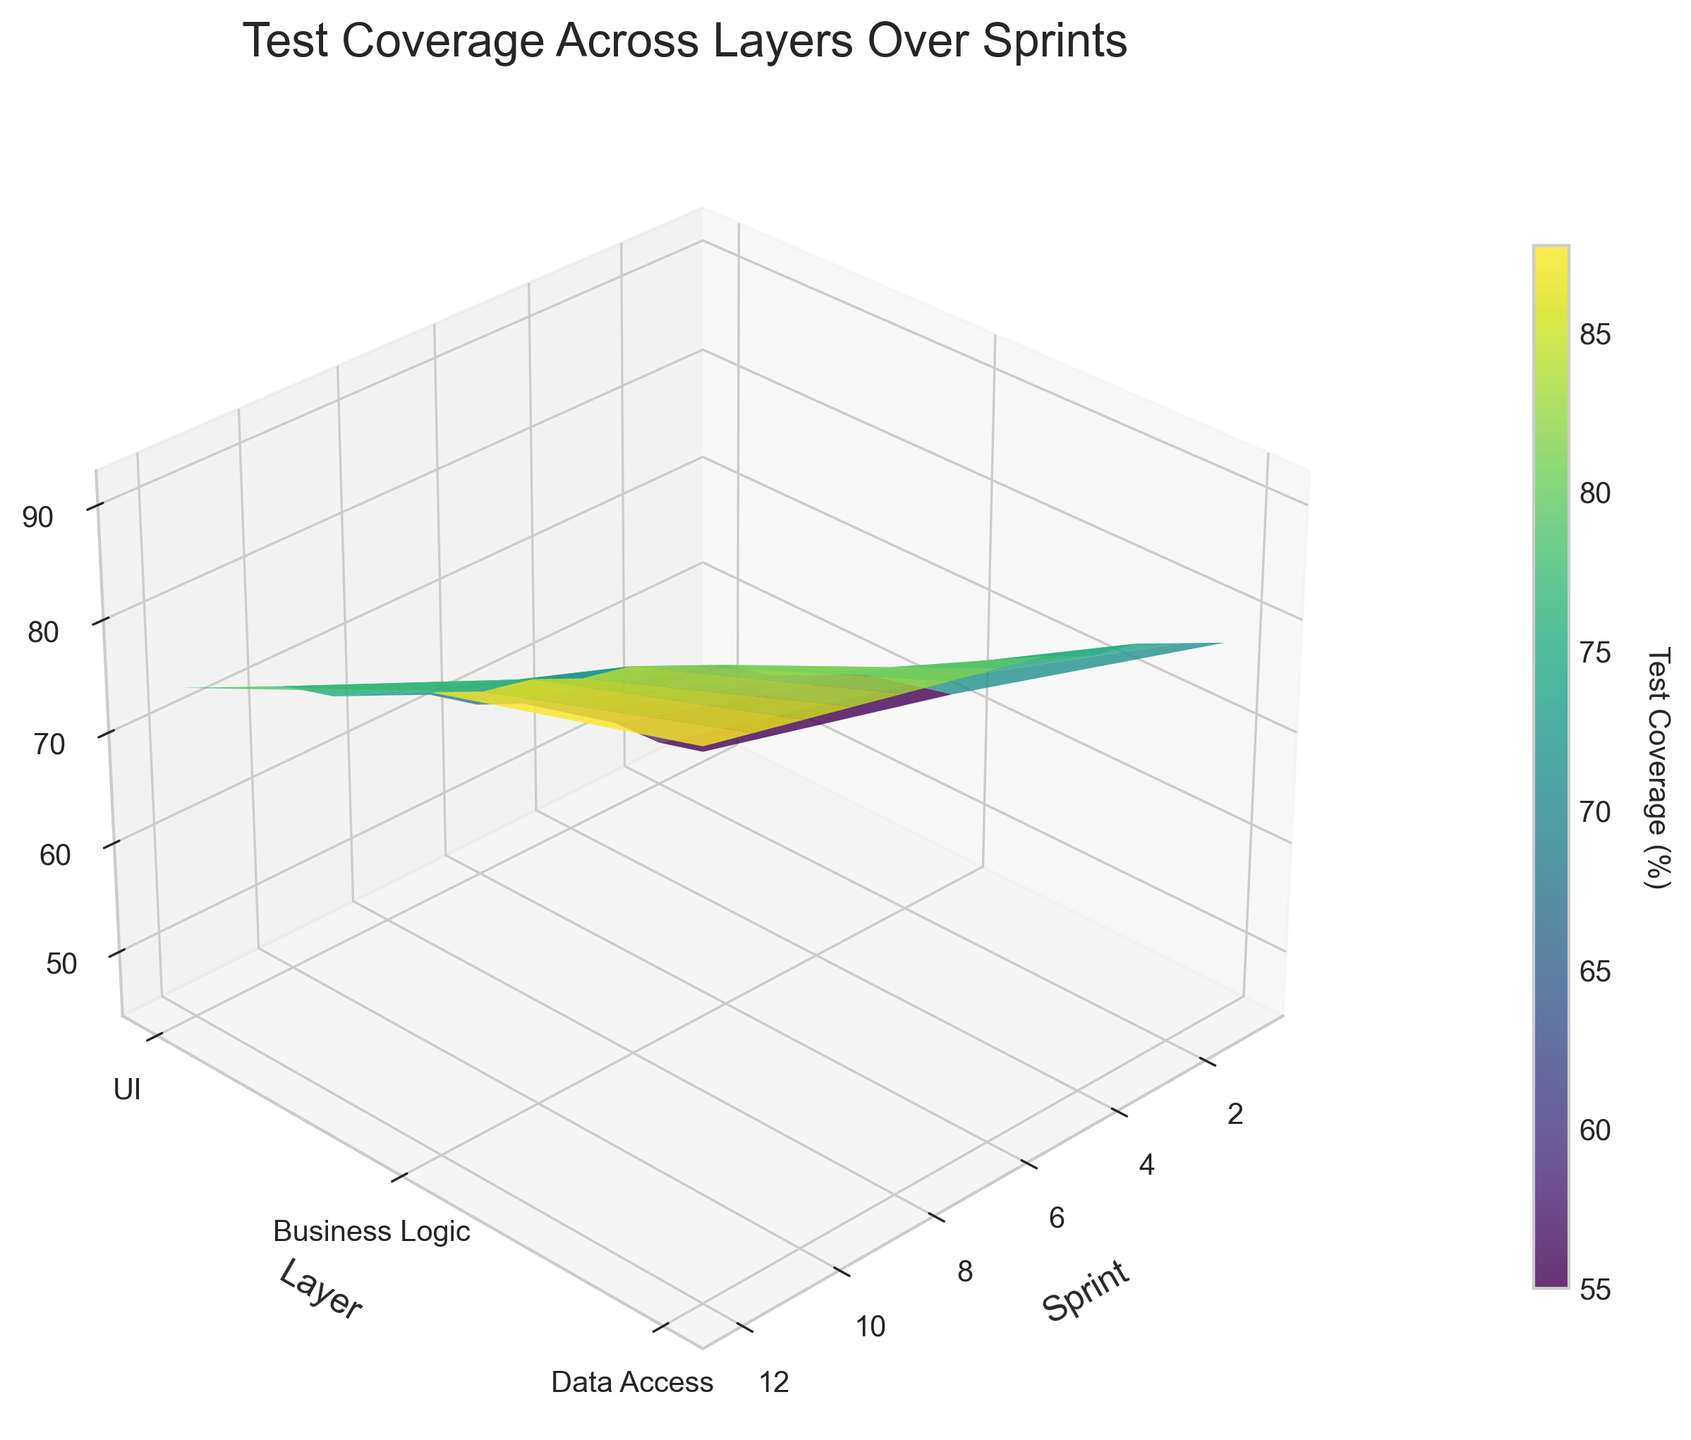What is the title of the plot? The title of the plot is positioned at the top center of the figure. It is displayed clearly in a large font.
Answer: Test Coverage Across Layers Over Sprints What are the labels for the X, Y, and Z axes? The labels for the axes are clearly marked along each axis. X is labeled “Sprint,” Y is labeled “Layer,” and Z is labeled “Test Coverage (%)”.
Answer: X: Sprint, Y: Layer, Z: Test Coverage (%) Which layer has the highest test coverage at Sprint 6? You need to identify the test coverage values for each layer at Sprint 6. Look at the specific point for Sprint 6 along the Z-axis for each layer mentioned along the Y-axis. The Data Access Layer has the highest value.
Answer: Data Access Layer How does the test coverage percentage for the UI Layer change from Sprint 1 to Sprint 12? Follow the trend along the Z-axis for the UI Layer from Sprint 1 to Sprint 12. You see an upward trend indicating that the test coverage for the UI Layer increases from around 45% to 74%.
Answer: Increases What is the difference in test coverage between the Business Logic Layer and the Data Access Layer at Sprint 8? Identify the Z-axis values for the Business Logic Layer and the Data Access Layer at Sprint 8, then calculate the difference between these two values. At Sprint 8, Business Logic Layer is at 79% and Data Access Layer is at 88%. The difference is 9%.
Answer: 9% Between which sprints does the test coverage for the Business Logic Layer show the most significant increase? Calculate the differences in test coverage between consecutive sprints for the Business Logic Layer and identify the interval with the highest increase. The most significant increase for the Business Logic Layer occurs between Sprint 5 and Sprint 6 (72% to 75%).
Answer: Between Sprint 5 and Sprint 6 Compare the test coverage trend of the UI Layer and the Business Logic Layer. Which layer shows a steeper increase? Evaluate the slope of the changes in the Z-axis for both layers. The UI Layer starts at 45% and ends at 74%, while the Business Logic Layer starts at 62% and ends at 85%. The UI Layer shows a steeper increase as it has a larger absolute change of 29% compared to 23% for the Business Logic Layer.
Answer: UI Layer What is the average test coverage for the Data Access Layer over the first 5 sprints? Sum the test coverage percentages for the Data Access Layer from Sprint 1 to Sprint 5, then divide by the number of sprints. (78 + 80 + 82 + 83 + 85) / 5 = 81.6%.
Answer: 81.6% 